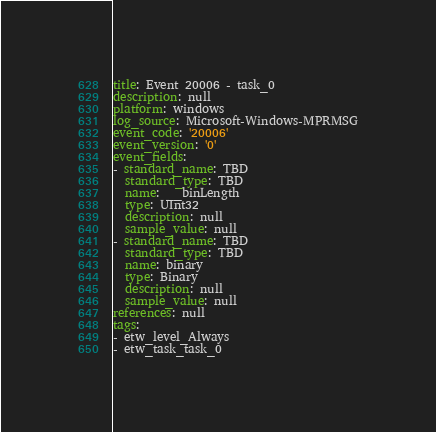<code> <loc_0><loc_0><loc_500><loc_500><_YAML_>title: Event 20006 - task_0
description: null
platform: windows
log_source: Microsoft-Windows-MPRMSG
event_code: '20006'
event_version: '0'
event_fields:
- standard_name: TBD
  standard_type: TBD
  name: __binLength
  type: UInt32
  description: null
  sample_value: null
- standard_name: TBD
  standard_type: TBD
  name: binary
  type: Binary
  description: null
  sample_value: null
references: null
tags:
- etw_level_Always
- etw_task_task_0
</code> 